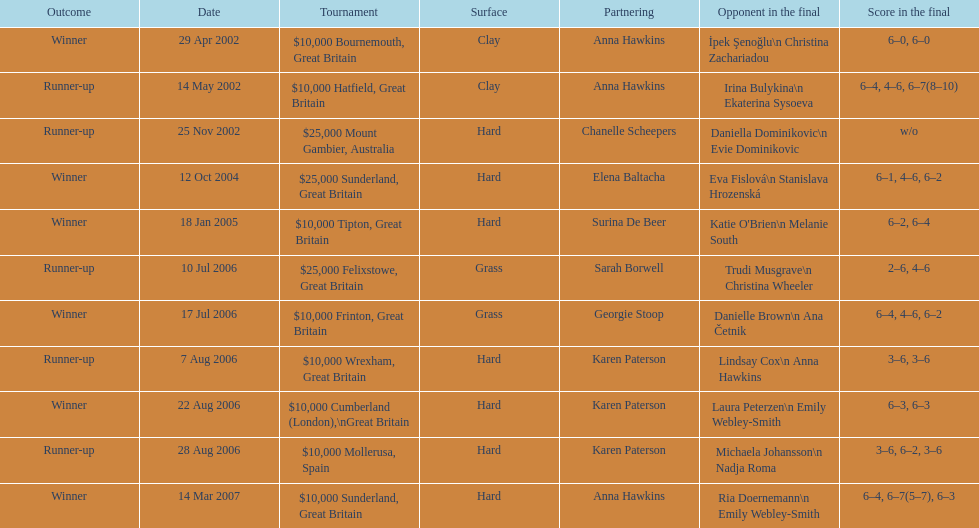How many surfaces are grass? 2. 